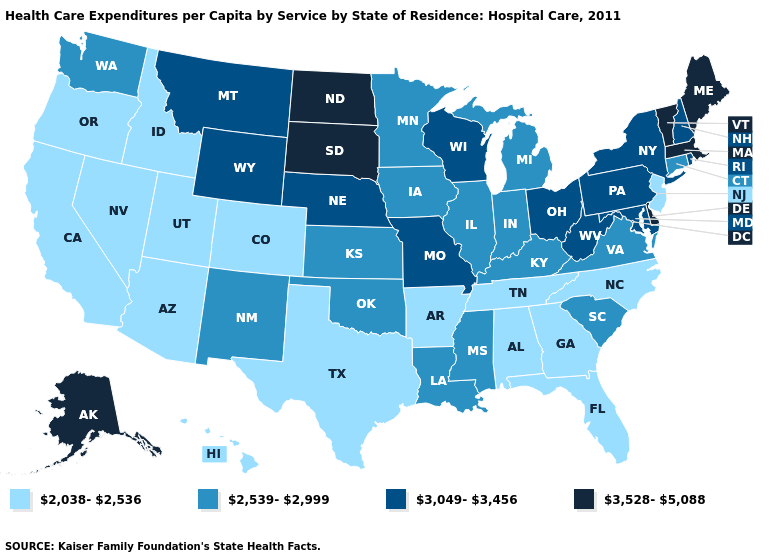Among the states that border Wisconsin , which have the lowest value?
Short answer required. Illinois, Iowa, Michigan, Minnesota. What is the lowest value in the South?
Answer briefly. 2,038-2,536. Name the states that have a value in the range 3,528-5,088?
Short answer required. Alaska, Delaware, Maine, Massachusetts, North Dakota, South Dakota, Vermont. Is the legend a continuous bar?
Short answer required. No. What is the value of Massachusetts?
Short answer required. 3,528-5,088. Does Iowa have the lowest value in the USA?
Concise answer only. No. Which states have the lowest value in the Northeast?
Give a very brief answer. New Jersey. What is the value of Vermont?
Give a very brief answer. 3,528-5,088. Name the states that have a value in the range 2,038-2,536?
Answer briefly. Alabama, Arizona, Arkansas, California, Colorado, Florida, Georgia, Hawaii, Idaho, Nevada, New Jersey, North Carolina, Oregon, Tennessee, Texas, Utah. What is the value of Kentucky?
Answer briefly. 2,539-2,999. Does the first symbol in the legend represent the smallest category?
Keep it brief. Yes. Among the states that border Illinois , which have the lowest value?
Keep it brief. Indiana, Iowa, Kentucky. What is the value of Wyoming?
Answer briefly. 3,049-3,456. Which states have the lowest value in the USA?
Quick response, please. Alabama, Arizona, Arkansas, California, Colorado, Florida, Georgia, Hawaii, Idaho, Nevada, New Jersey, North Carolina, Oregon, Tennessee, Texas, Utah. 